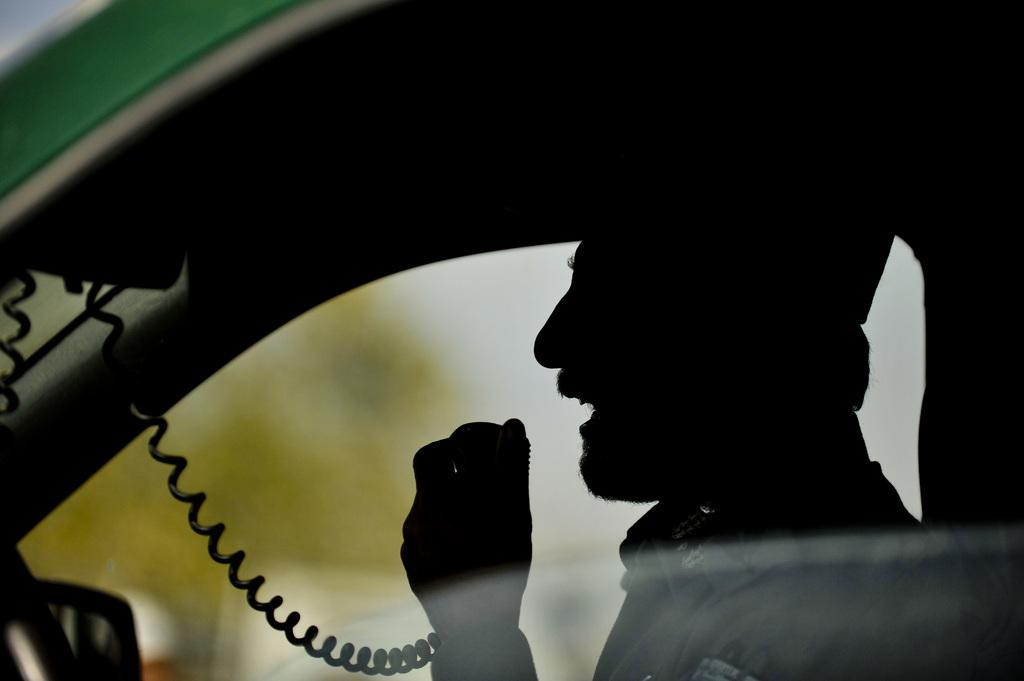Who is present in the image? There is a person in the image. What is the person doing in the image? The person is sitting in a car. Where is the car located in the image? The car is on the right side of the image. What activity is the person engaged in while sitting in the car? The person is talking on the phone. What is the smell of the spring in the image? There is no mention of spring or any smell in the image; it only features a person sitting in a car and talking on the phone. 